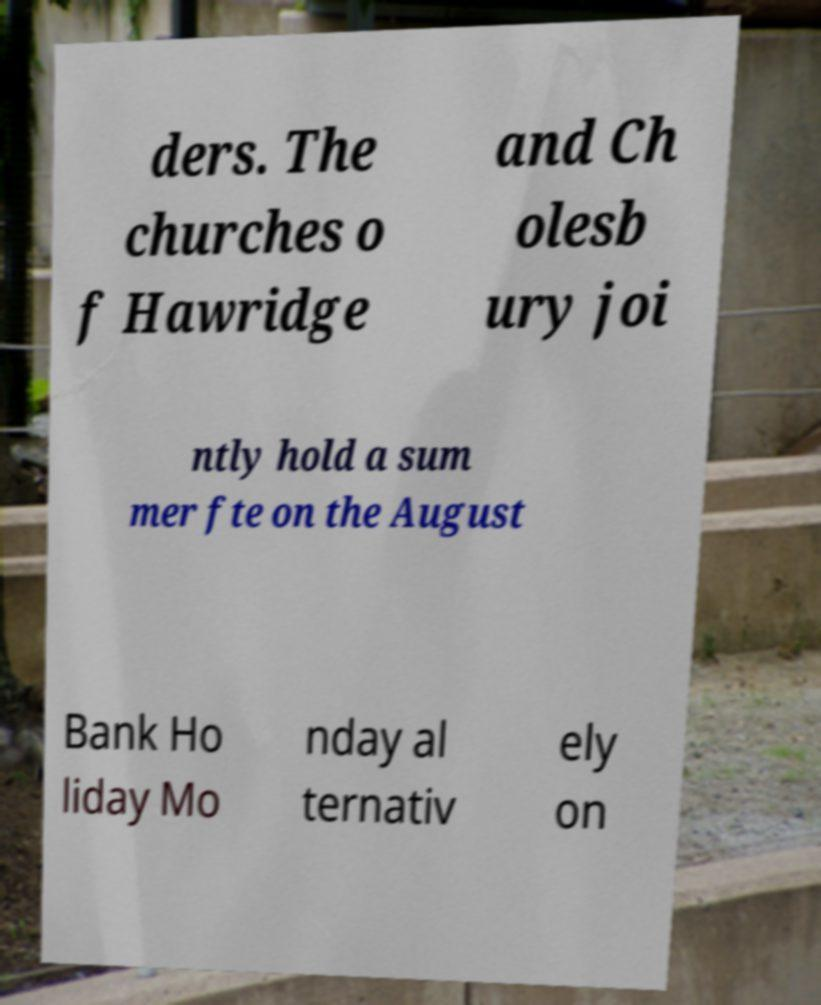Can you accurately transcribe the text from the provided image for me? ders. The churches o f Hawridge and Ch olesb ury joi ntly hold a sum mer fte on the August Bank Ho liday Mo nday al ternativ ely on 